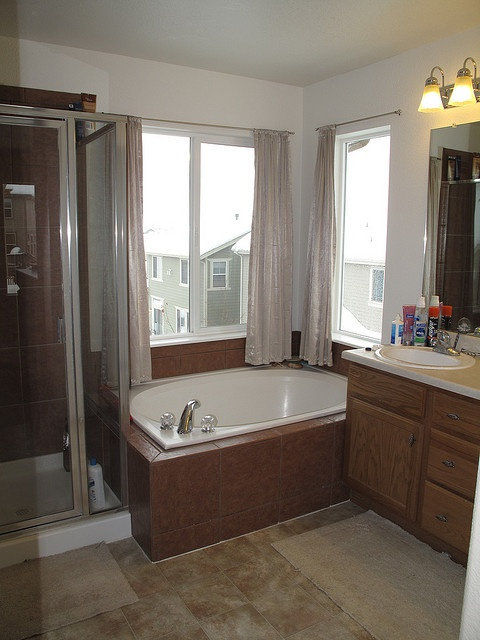Describe the objects in this image and their specific colors. I can see sink in black, darkgray, tan, and gray tones, bottle in black, gray, darkgray, and navy tones, bottle in black, gray, brown, purple, and maroon tones, and bottle in black, darkgray, tan, teal, and gray tones in this image. 